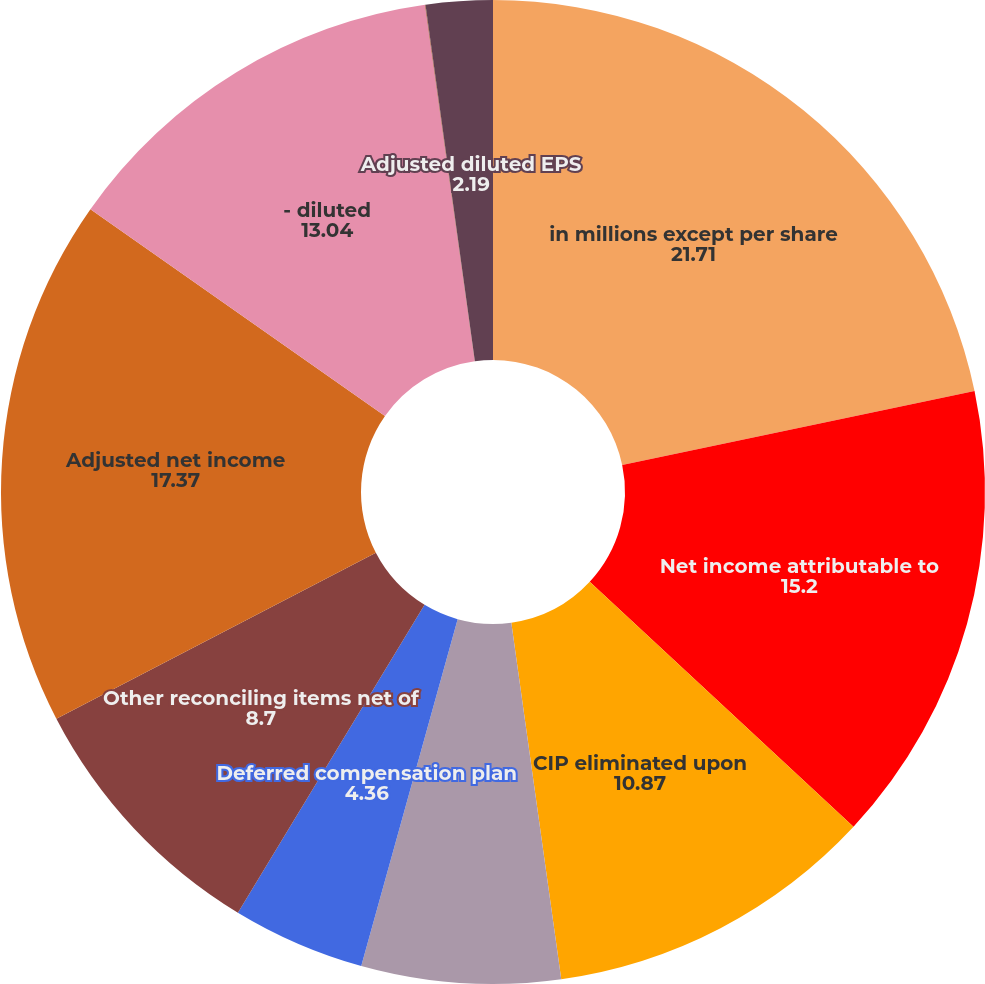<chart> <loc_0><loc_0><loc_500><loc_500><pie_chart><fcel>in millions except per share<fcel>Net income attributable to<fcel>CIP eliminated upon<fcel>Business combinations net of<fcel>Deferred compensation plan<fcel>Other reconciling items net of<fcel>Adjusted net income<fcel>- diluted<fcel>Diluted EPS<fcel>Adjusted diluted EPS<nl><fcel>21.71%<fcel>15.2%<fcel>10.87%<fcel>6.53%<fcel>4.36%<fcel>8.7%<fcel>17.37%<fcel>13.04%<fcel>0.02%<fcel>2.19%<nl></chart> 